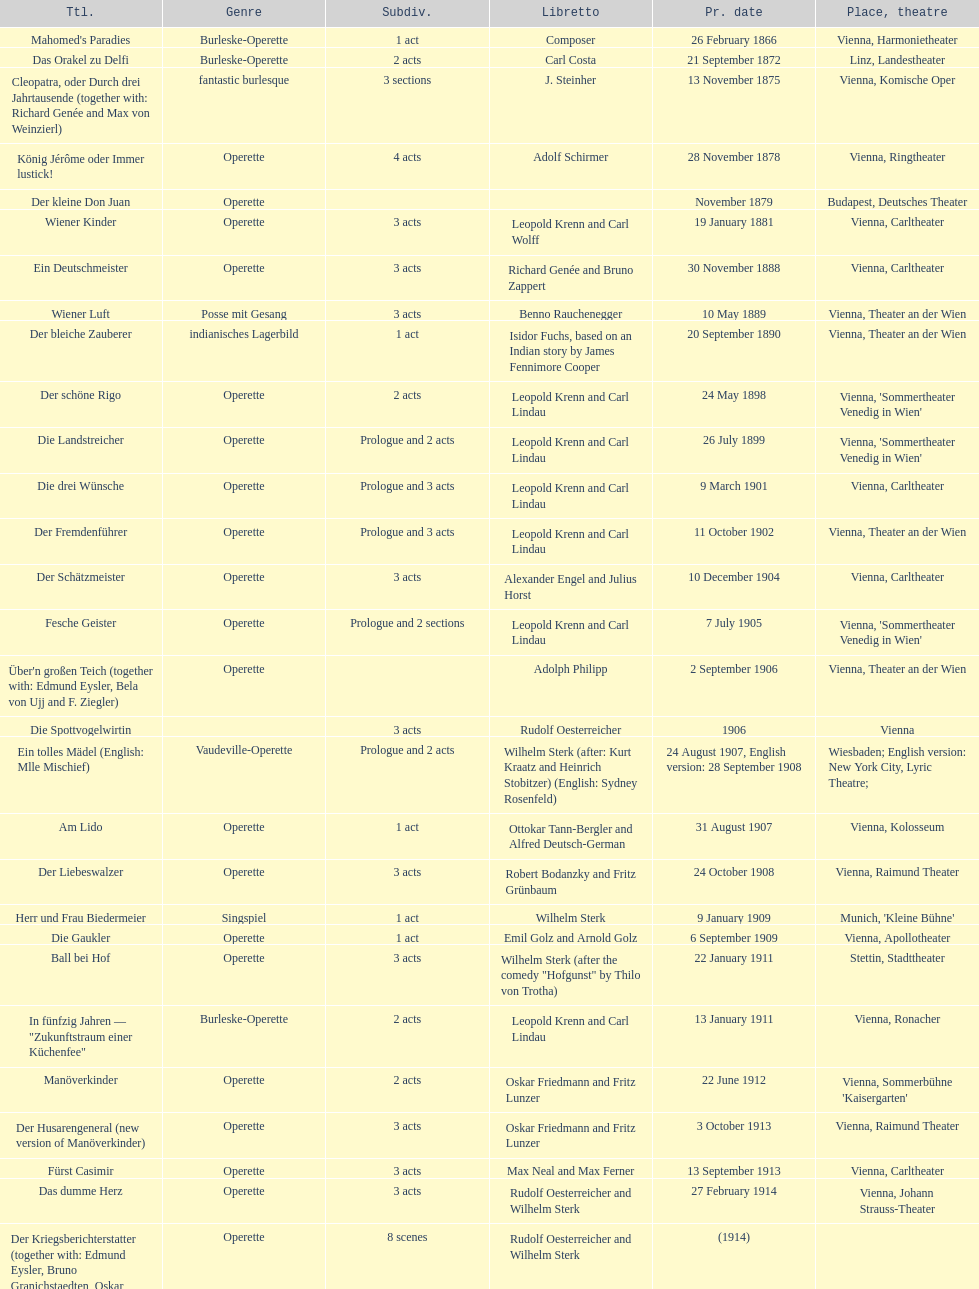Does der liebeswalzer or manöverkinder contain more acts? Der Liebeswalzer. 